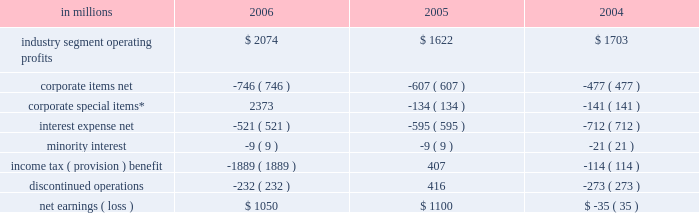Item 7 .
Management 2019s discussion and analysis of financial condition and results of operations executive summary international paper 2019s operating results in 2006 bene- fited from strong gains in pricing and sales volumes and lower operating costs .
Our average paper and packaging prices in 2006 increased faster than our costs for the first time in four years .
The improve- ment in sales volumes reflects increased uncoated papers , corrugated box , coated paperboard and european papers shipments , as well as improved revenues from our xpedx distribution business .
Our manufacturing operations also made solid cost reduction improvements .
Lower interest expense , reflecting debt repayments in 2005 and 2006 , was also a positive factor .
Together , these improvements more than offset the effects of continued high raw material and distribution costs , lower real estate sales , higher net corporate expenses and lower con- tributions from businesses and forestlands divested during 2006 .
Looking forward to 2007 , we expect seasonally higher sales volumes in the first quarter .
Average paper price realizations should continue to improve as we implement previously announced price increases in europe and brazil .
Input costs for energy , fiber and chemicals are expected to be mixed , although slightly higher in the first quarter .
Operating results will benefit from the recently completed international paper/sun paperboard joint ventures in china and the addition of the luiz anto- nio paper mill to our operations in brazil .
However , primarily as a result of lower real estate sales in the first quarter , we anticipate earnings from continuing operations will be somewhat lower than in the 2006 fourth quarter .
Significant steps were also taken in 2006 in the execution of the company 2019s transformation plan .
We completed the sales of our u.s .
And brazilian coated papers businesses and 5.6 million acres of u.s .
Forestlands , and announced definitive sale agreements for our kraft papers , beverage pack- aging and arizona chemical businesses and a majority of our wood products business , all expected to close during 2007 .
Through december 31 , 2006 , we have received approximately $ 9.7 billion of the estimated proceeds from divest- itures announced under this plan of approximately $ 11.3 billion , with the balance to be received as the remaining divestitures are completed in the first half of 2007 .
We have strengthened our balance sheet by reducing debt by $ 6.2 billion , and returned value to our shareholders by repurchasing 39.7 million shares of our common stock for approximately $ 1.4 billion .
We made a $ 1.0 billion voluntary contribution to our u.s .
Qualified pension fund .
We have identified selective reinvestment opportunities totaling approx- imately $ 2.0 billion , including opportunities in china , brazil and russia .
Finally , we remain focused on our three-year $ 1.2 billion target for non-price profit- ability improvements , with $ 330 million realized during 2006 .
While more remains to be done in 2007 , we have made substantial progress toward achiev- ing the objectives announced at the outset of the plan in july 2005 .
Results of operations industry segment operating profits are used by inter- national paper 2019s management to measure the earn- ings performance of its businesses .
Management believes that this measure allows a better under- standing of trends in costs , operating efficiencies , prices and volumes .
Industry segment operating profits are defined as earnings before taxes and minority interest , interest expense , corporate items and corporate special items .
Industry segment oper- ating profits are defined by the securities and exchange commission as a non-gaap financial measure , and are not gaap alternatives to net income or any other operating measure prescribed by accounting principles generally accepted in the united states .
International paper operates in six segments : print- ing papers , industrial packaging , consumer pack- aging , distribution , forest products and specialty businesses and other .
The table shows the components of net earnings ( loss ) for each of the last three years : in millions 2006 2005 2004 .
* corporate special items include gains on transformation plan forestland sales , goodwill impairment charges , restructuring and other charges , net losses on sales and impairments of businesses , insurance recoveries and reversals of reserves no longer required. .
What was the percentage change in industry segment operating profits from 2004 to 2005? 
Computations: ((1622 - 1703) / 1703)
Answer: -0.04756. 